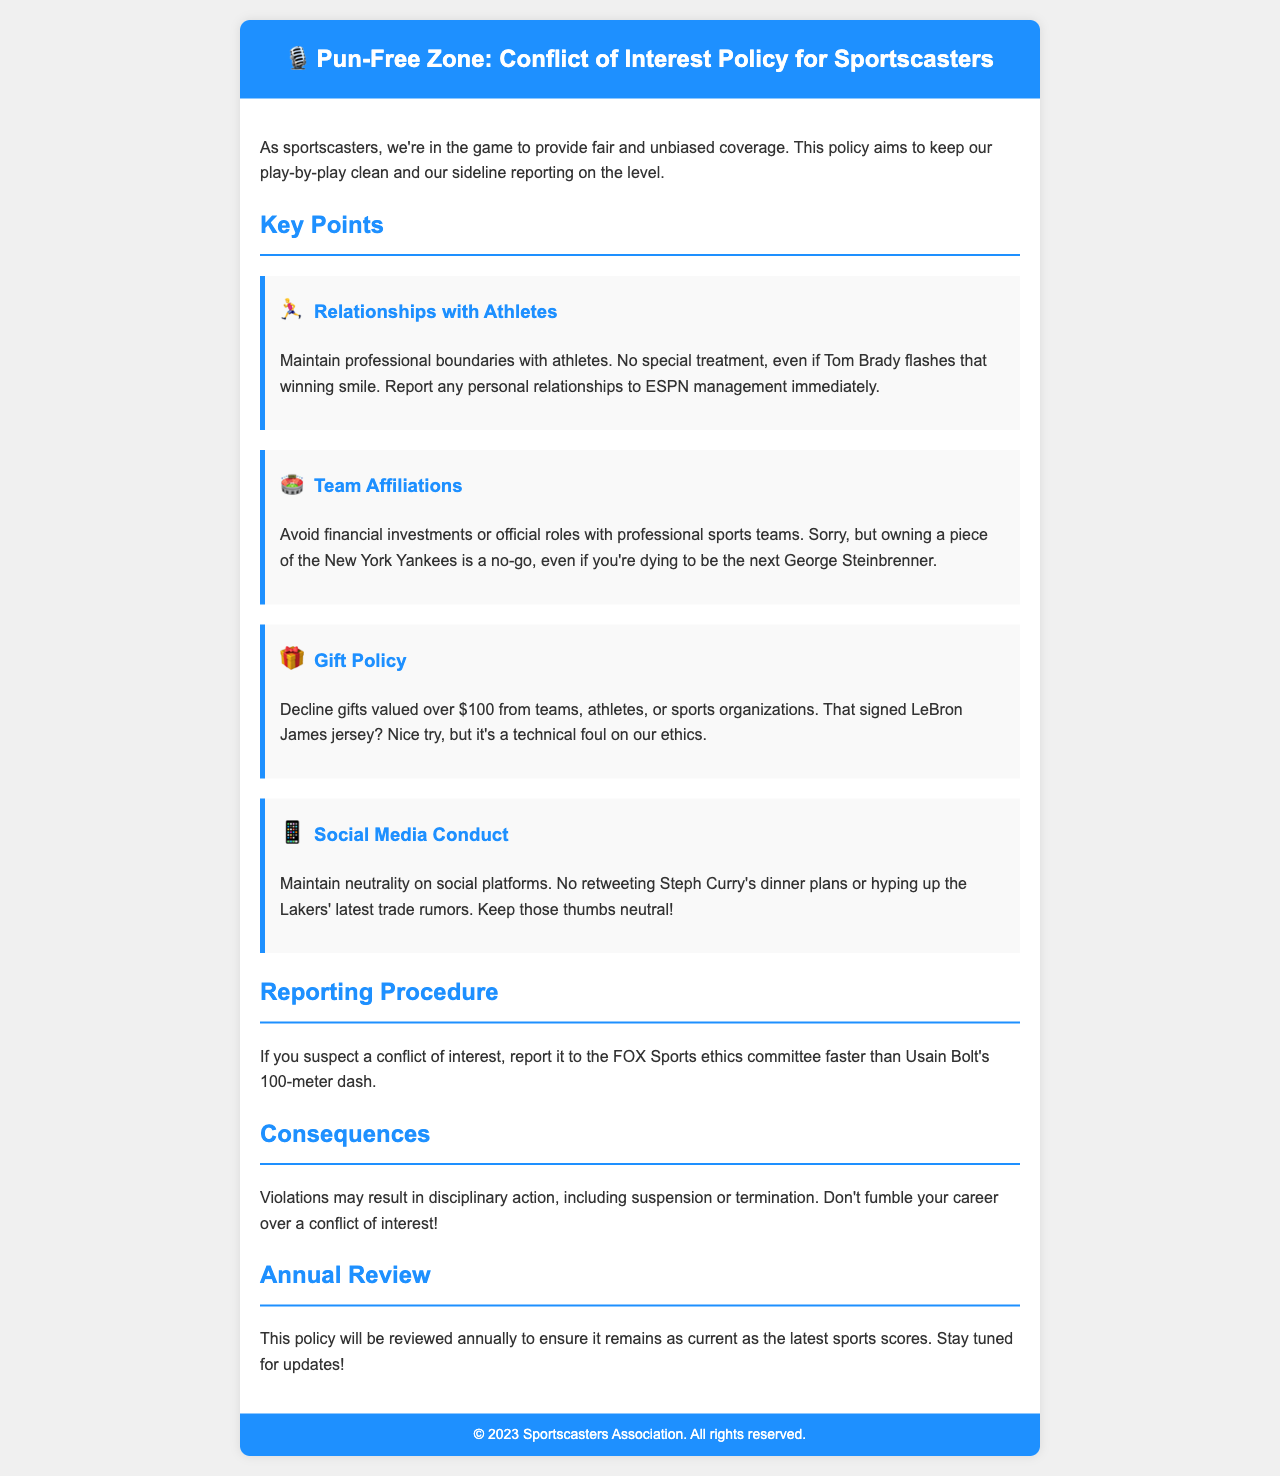What is the title of the policy document? The title is prominently displayed at the top of the document and is "Pun-Free Zone: Conflict of Interest Policy for Sportscasters."
Answer: Pun-Free Zone: Conflict of Interest Policy for Sportscasters What must sportscasters maintain with athletes? The document specifies the need to maintain professional boundaries with athletes to avoid conflicts of interest.
Answer: Professional boundaries What is the maximum value of gifts sportscasters can accept? The policy states that gifts valued over $100 from teams, athletes, or sports organizations should be declined.
Answer: $100 What is the reporting procedure mentioned for conflicts of interest? The procedure indicates that if a conflict is suspected, it should be reported to the FOX Sports ethics committee.
Answer: FOX Sports ethics committee What may result from violating the conflict of interest policy? The document outlines that violations may lead to disciplinary actions, which could include suspension or termination.
Answer: Suspension or termination How often will the policy be reviewed? The document mentions that the policy will be reviewed annually, ensuring it stays current.
Answer: Annually What is one example of a relationship sportscasters must report? The policy mentions that any personal relationships with athletes must be reported to ESPN management immediately.
Answer: Personal relationships with athletes 